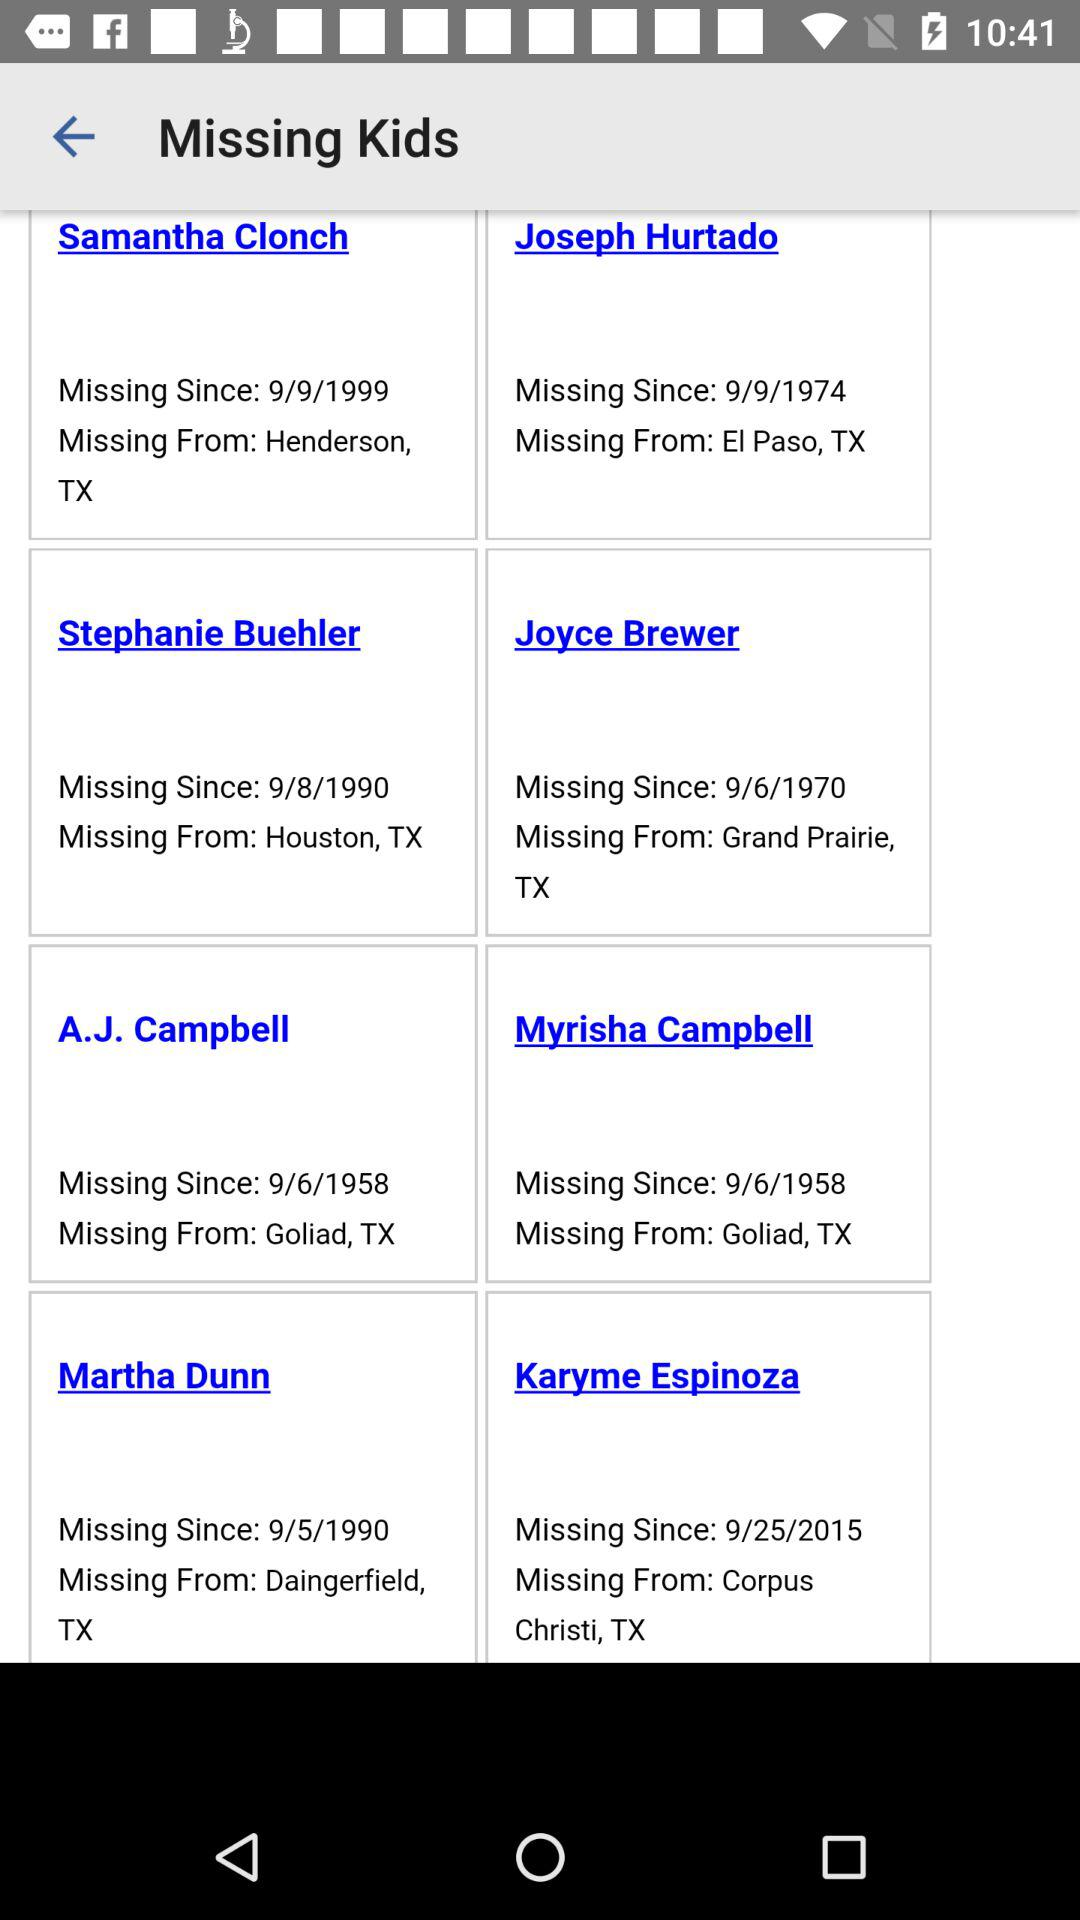What is the place from which A.J. Campbell is missing? The place from which A.J. Campbell is missing is Goliad, TX. 